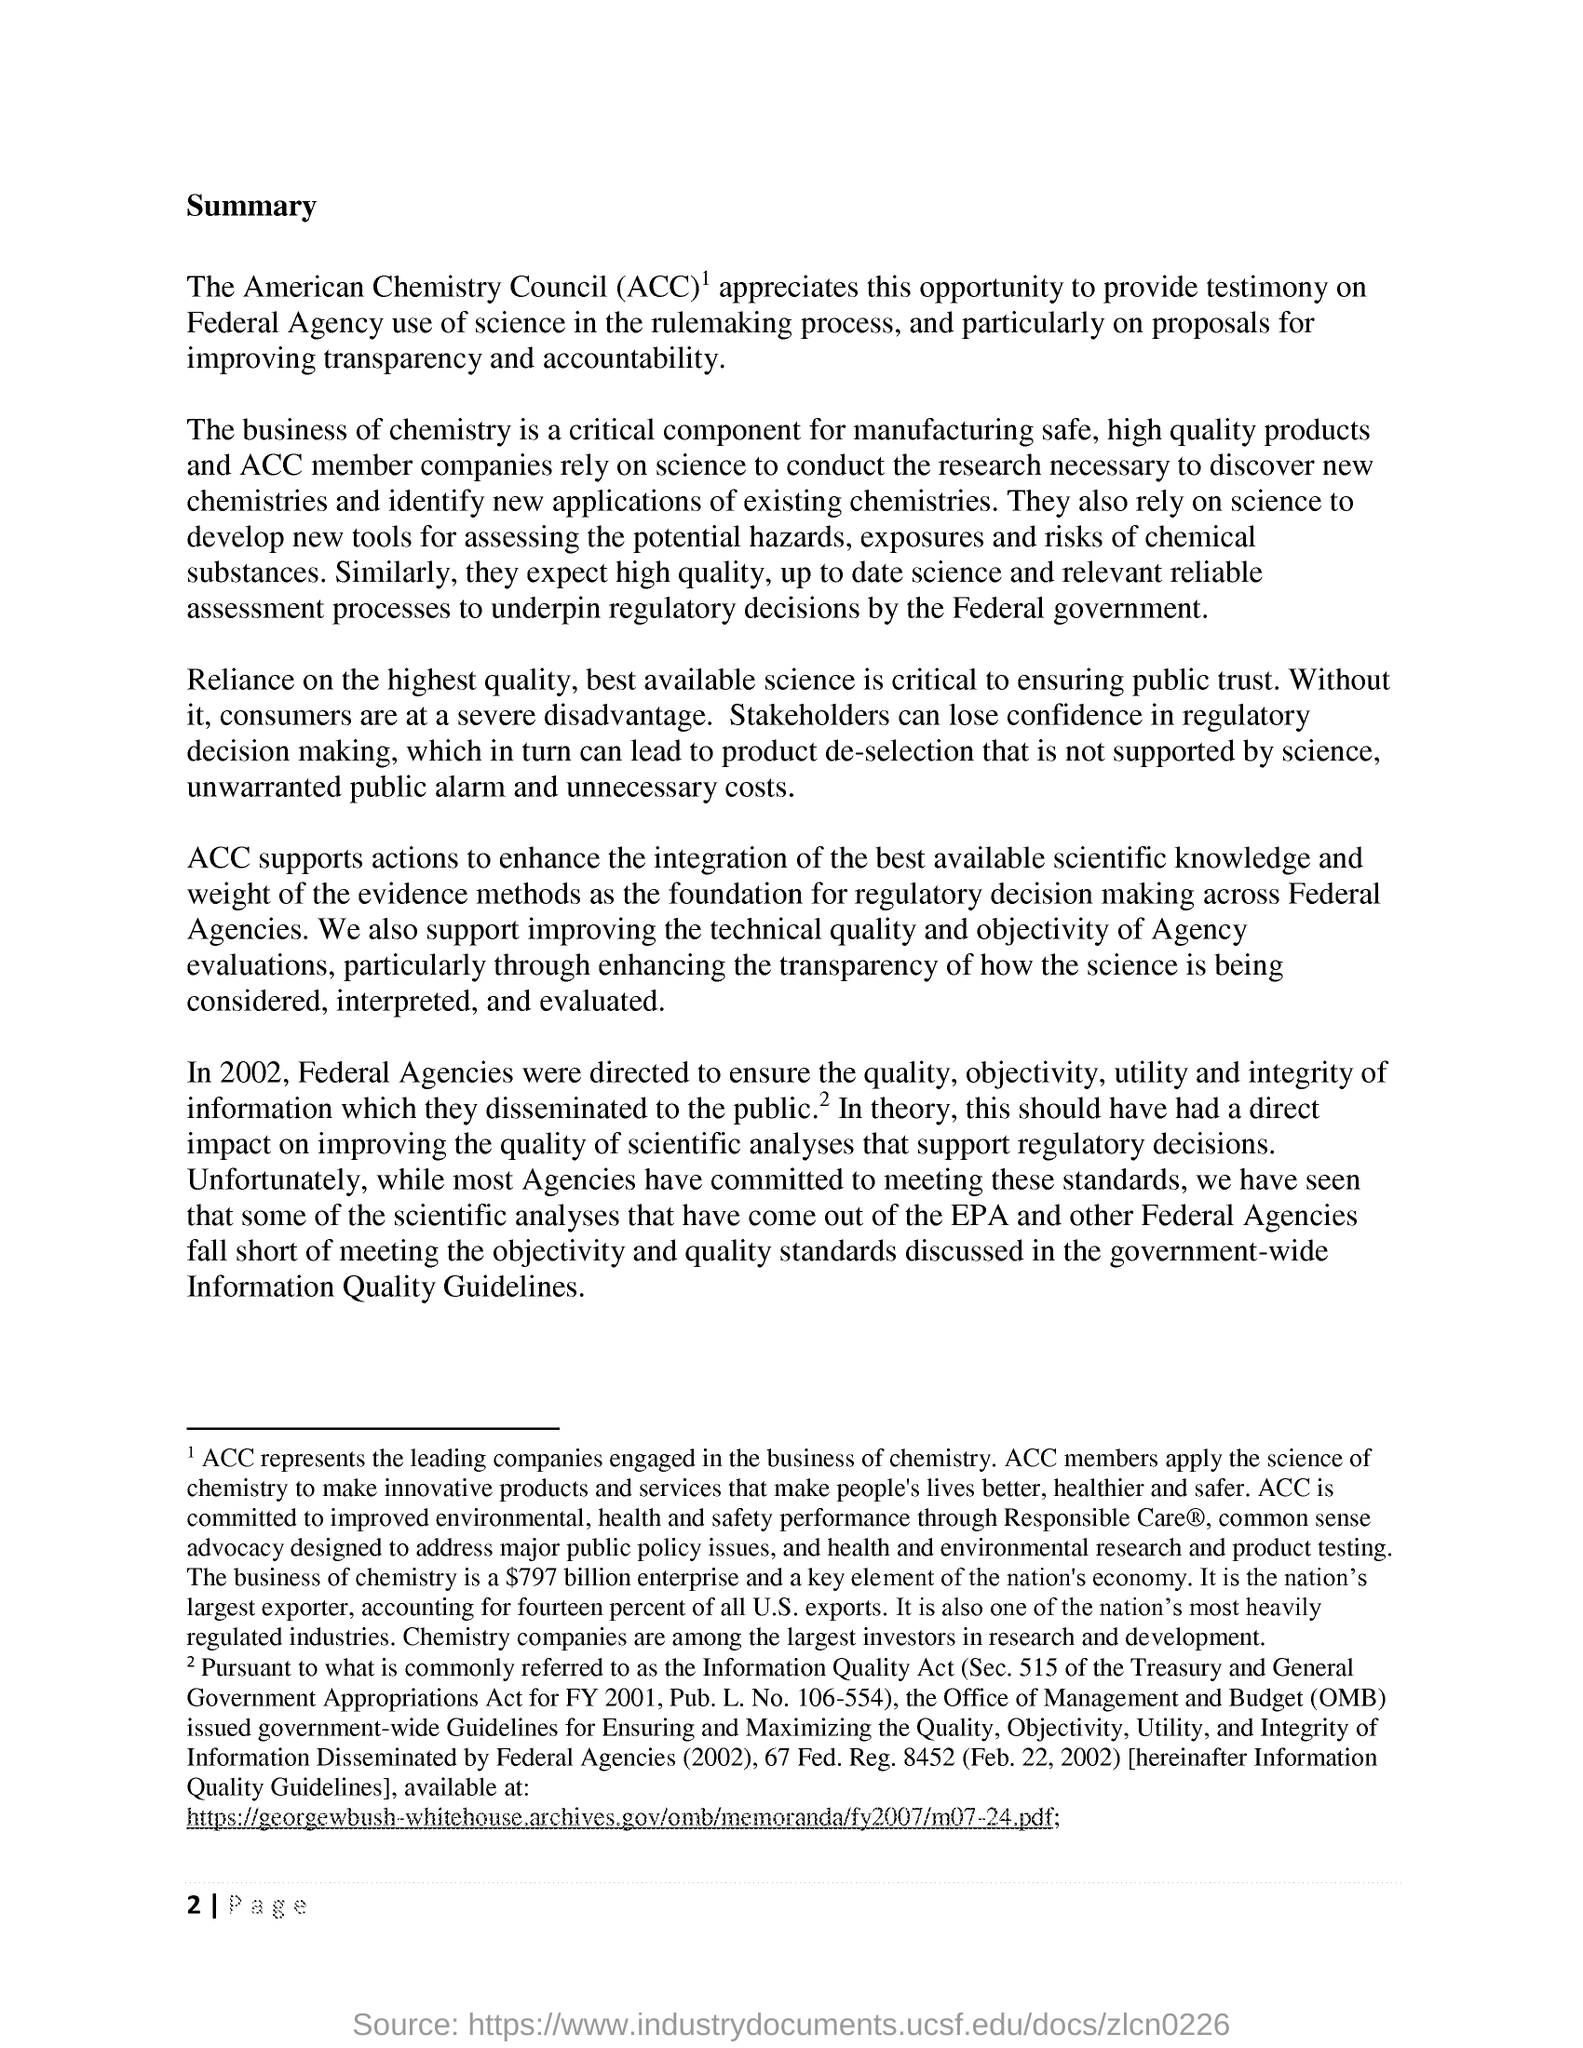What is the first title in the document?
Offer a terse response. Summary. What is the full form of ACC?
Ensure brevity in your answer.  American Chemistry Council. 